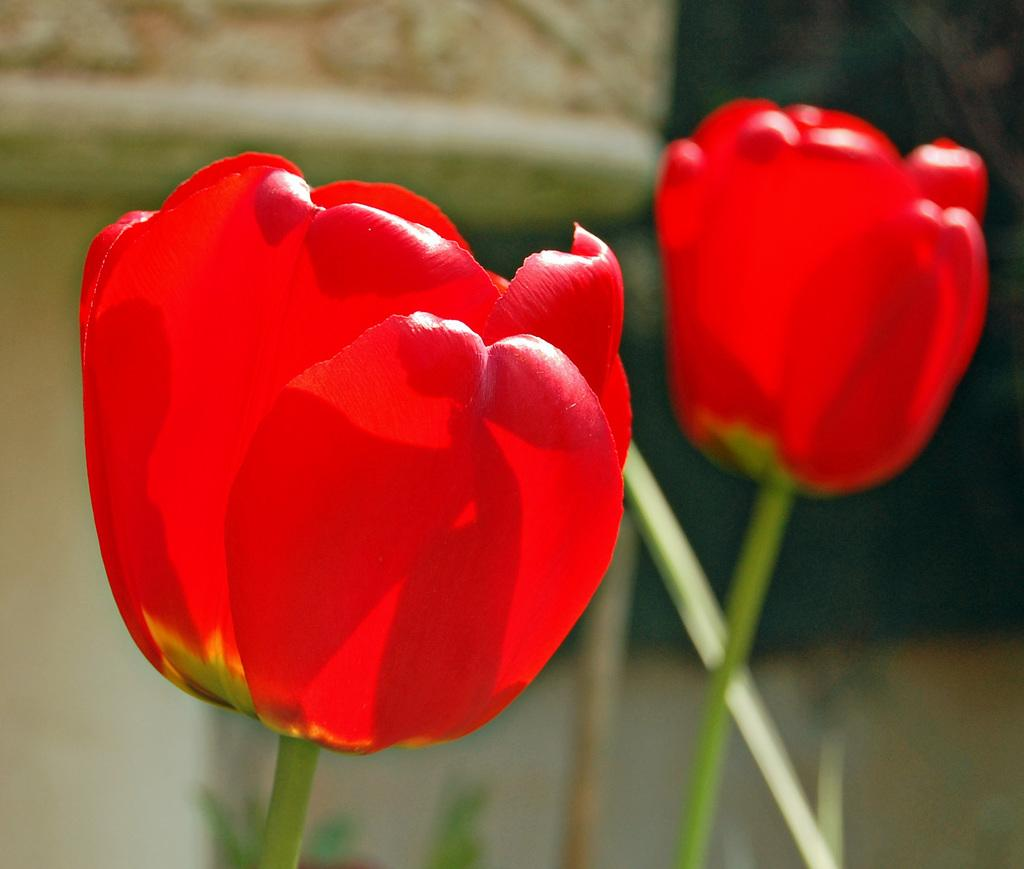What type of flowers can be seen in the image? There are red flowers in the image. What else is visible besides the flowers? There are stems and green leaves in the image. Can you describe the background of the image? The background of the image is blurry. What type of voice can be heard coming from the rat in the image? There is no rat present in the image, and therefore no voice can be heard. 